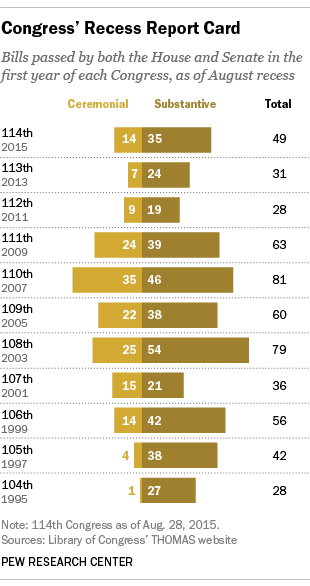Highlight a few significant elements in this photo. In 2003, 54 substantive bills were passed by Congress. In 2007, the maximum number of bills were passed by the Congress. 